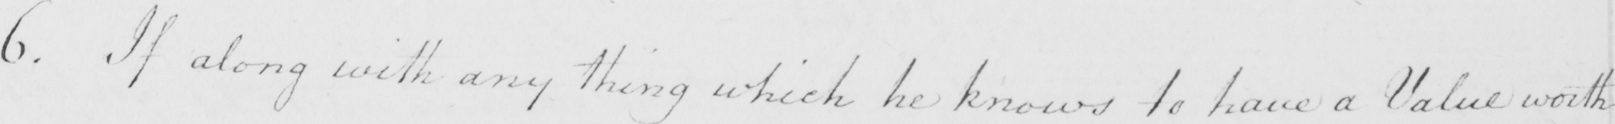Transcribe the text shown in this historical manuscript line. 6 . If along with any thing which he knows to have a Value worth 